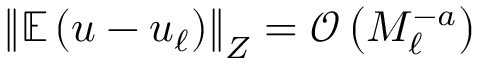Convert formula to latex. <formula><loc_0><loc_0><loc_500><loc_500>\left \| \mathbb { E } \left ( u - u _ { \ell } \right ) \right \| _ { Z } = \mathcal { O } \left ( M _ { \ell } ^ { - a } \right )</formula> 